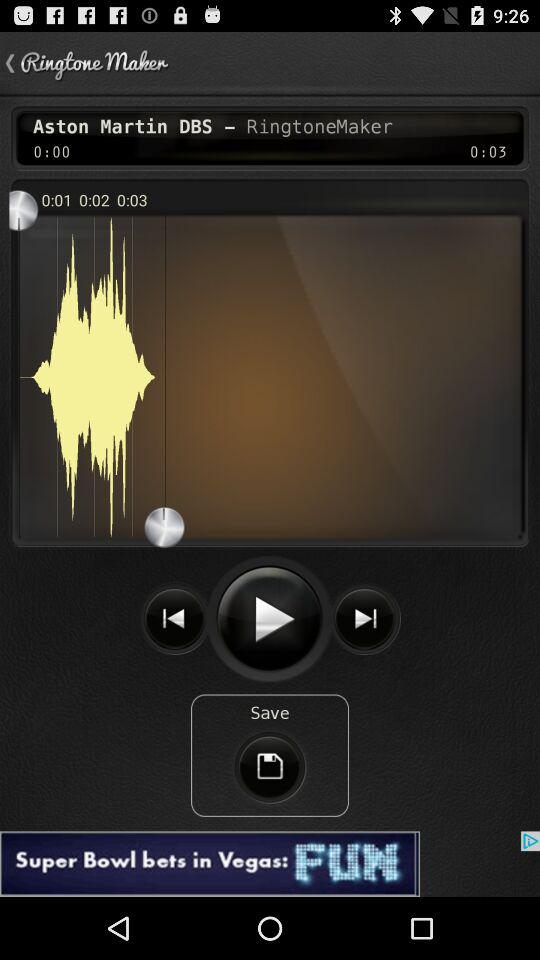How many more seconds are in the song than the time stamp?
Answer the question using a single word or phrase. 3 